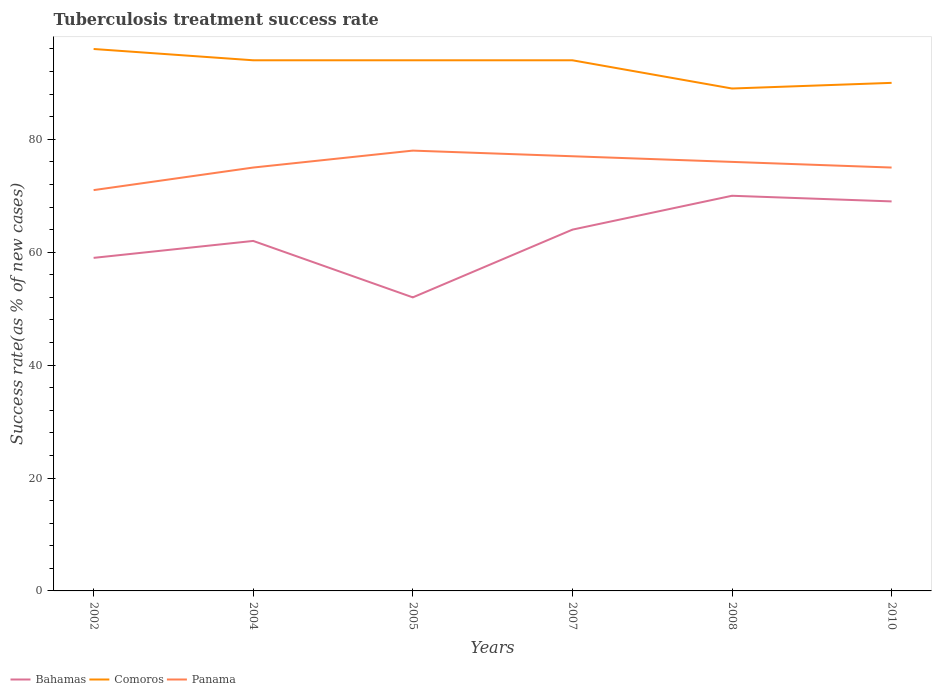Does the line corresponding to Bahamas intersect with the line corresponding to Panama?
Provide a short and direct response. No. In which year was the tuberculosis treatment success rate in Bahamas maximum?
Your answer should be compact. 2005. What is the total tuberculosis treatment success rate in Comoros in the graph?
Your response must be concise. 0. What is the difference between the highest and the second highest tuberculosis treatment success rate in Comoros?
Provide a short and direct response. 7. What is the difference between the highest and the lowest tuberculosis treatment success rate in Bahamas?
Offer a very short reply. 3. Is the tuberculosis treatment success rate in Panama strictly greater than the tuberculosis treatment success rate in Comoros over the years?
Ensure brevity in your answer.  Yes. How many lines are there?
Your answer should be very brief. 3. What is the difference between two consecutive major ticks on the Y-axis?
Ensure brevity in your answer.  20. Does the graph contain any zero values?
Provide a succinct answer. No. How many legend labels are there?
Keep it short and to the point. 3. How are the legend labels stacked?
Your response must be concise. Horizontal. What is the title of the graph?
Ensure brevity in your answer.  Tuberculosis treatment success rate. Does "Grenada" appear as one of the legend labels in the graph?
Provide a succinct answer. No. What is the label or title of the Y-axis?
Offer a very short reply. Success rate(as % of new cases). What is the Success rate(as % of new cases) of Bahamas in 2002?
Ensure brevity in your answer.  59. What is the Success rate(as % of new cases) of Comoros in 2002?
Your answer should be very brief. 96. What is the Success rate(as % of new cases) in Comoros in 2004?
Provide a succinct answer. 94. What is the Success rate(as % of new cases) in Bahamas in 2005?
Offer a very short reply. 52. What is the Success rate(as % of new cases) of Comoros in 2005?
Give a very brief answer. 94. What is the Success rate(as % of new cases) of Panama in 2005?
Ensure brevity in your answer.  78. What is the Success rate(as % of new cases) of Bahamas in 2007?
Give a very brief answer. 64. What is the Success rate(as % of new cases) in Comoros in 2007?
Offer a very short reply. 94. What is the Success rate(as % of new cases) in Bahamas in 2008?
Your response must be concise. 70. What is the Success rate(as % of new cases) in Comoros in 2008?
Provide a short and direct response. 89. What is the Success rate(as % of new cases) of Comoros in 2010?
Keep it short and to the point. 90. Across all years, what is the maximum Success rate(as % of new cases) in Bahamas?
Make the answer very short. 70. Across all years, what is the maximum Success rate(as % of new cases) of Comoros?
Offer a terse response. 96. Across all years, what is the maximum Success rate(as % of new cases) in Panama?
Your answer should be very brief. 78. Across all years, what is the minimum Success rate(as % of new cases) of Bahamas?
Keep it short and to the point. 52. Across all years, what is the minimum Success rate(as % of new cases) of Comoros?
Your answer should be compact. 89. Across all years, what is the minimum Success rate(as % of new cases) in Panama?
Offer a terse response. 71. What is the total Success rate(as % of new cases) in Bahamas in the graph?
Your answer should be very brief. 376. What is the total Success rate(as % of new cases) of Comoros in the graph?
Your answer should be compact. 557. What is the total Success rate(as % of new cases) in Panama in the graph?
Ensure brevity in your answer.  452. What is the difference between the Success rate(as % of new cases) in Panama in 2002 and that in 2004?
Give a very brief answer. -4. What is the difference between the Success rate(as % of new cases) of Panama in 2002 and that in 2007?
Provide a short and direct response. -6. What is the difference between the Success rate(as % of new cases) of Bahamas in 2002 and that in 2008?
Offer a very short reply. -11. What is the difference between the Success rate(as % of new cases) in Comoros in 2002 and that in 2008?
Your answer should be compact. 7. What is the difference between the Success rate(as % of new cases) in Comoros in 2002 and that in 2010?
Your answer should be compact. 6. What is the difference between the Success rate(as % of new cases) of Bahamas in 2004 and that in 2007?
Provide a short and direct response. -2. What is the difference between the Success rate(as % of new cases) in Panama in 2004 and that in 2008?
Your answer should be compact. -1. What is the difference between the Success rate(as % of new cases) in Panama in 2004 and that in 2010?
Keep it short and to the point. 0. What is the difference between the Success rate(as % of new cases) of Comoros in 2005 and that in 2007?
Provide a succinct answer. 0. What is the difference between the Success rate(as % of new cases) of Panama in 2005 and that in 2007?
Give a very brief answer. 1. What is the difference between the Success rate(as % of new cases) of Comoros in 2005 and that in 2008?
Your answer should be very brief. 5. What is the difference between the Success rate(as % of new cases) in Panama in 2005 and that in 2008?
Your response must be concise. 2. What is the difference between the Success rate(as % of new cases) in Bahamas in 2005 and that in 2010?
Your answer should be very brief. -17. What is the difference between the Success rate(as % of new cases) of Comoros in 2005 and that in 2010?
Your answer should be very brief. 4. What is the difference between the Success rate(as % of new cases) of Bahamas in 2007 and that in 2008?
Offer a very short reply. -6. What is the difference between the Success rate(as % of new cases) in Comoros in 2007 and that in 2010?
Give a very brief answer. 4. What is the difference between the Success rate(as % of new cases) of Panama in 2007 and that in 2010?
Keep it short and to the point. 2. What is the difference between the Success rate(as % of new cases) of Bahamas in 2008 and that in 2010?
Ensure brevity in your answer.  1. What is the difference between the Success rate(as % of new cases) in Comoros in 2008 and that in 2010?
Make the answer very short. -1. What is the difference between the Success rate(as % of new cases) in Panama in 2008 and that in 2010?
Your response must be concise. 1. What is the difference between the Success rate(as % of new cases) in Bahamas in 2002 and the Success rate(as % of new cases) in Comoros in 2004?
Ensure brevity in your answer.  -35. What is the difference between the Success rate(as % of new cases) of Bahamas in 2002 and the Success rate(as % of new cases) of Panama in 2004?
Provide a short and direct response. -16. What is the difference between the Success rate(as % of new cases) in Bahamas in 2002 and the Success rate(as % of new cases) in Comoros in 2005?
Offer a terse response. -35. What is the difference between the Success rate(as % of new cases) of Bahamas in 2002 and the Success rate(as % of new cases) of Panama in 2005?
Your answer should be very brief. -19. What is the difference between the Success rate(as % of new cases) of Comoros in 2002 and the Success rate(as % of new cases) of Panama in 2005?
Offer a very short reply. 18. What is the difference between the Success rate(as % of new cases) in Bahamas in 2002 and the Success rate(as % of new cases) in Comoros in 2007?
Your answer should be very brief. -35. What is the difference between the Success rate(as % of new cases) in Bahamas in 2002 and the Success rate(as % of new cases) in Comoros in 2008?
Provide a short and direct response. -30. What is the difference between the Success rate(as % of new cases) of Comoros in 2002 and the Success rate(as % of new cases) of Panama in 2008?
Offer a terse response. 20. What is the difference between the Success rate(as % of new cases) in Bahamas in 2002 and the Success rate(as % of new cases) in Comoros in 2010?
Give a very brief answer. -31. What is the difference between the Success rate(as % of new cases) of Bahamas in 2002 and the Success rate(as % of new cases) of Panama in 2010?
Provide a succinct answer. -16. What is the difference between the Success rate(as % of new cases) in Bahamas in 2004 and the Success rate(as % of new cases) in Comoros in 2005?
Your response must be concise. -32. What is the difference between the Success rate(as % of new cases) in Bahamas in 2004 and the Success rate(as % of new cases) in Comoros in 2007?
Your response must be concise. -32. What is the difference between the Success rate(as % of new cases) of Comoros in 2004 and the Success rate(as % of new cases) of Panama in 2010?
Give a very brief answer. 19. What is the difference between the Success rate(as % of new cases) in Bahamas in 2005 and the Success rate(as % of new cases) in Comoros in 2007?
Your answer should be very brief. -42. What is the difference between the Success rate(as % of new cases) in Comoros in 2005 and the Success rate(as % of new cases) in Panama in 2007?
Your answer should be compact. 17. What is the difference between the Success rate(as % of new cases) of Bahamas in 2005 and the Success rate(as % of new cases) of Comoros in 2008?
Your answer should be very brief. -37. What is the difference between the Success rate(as % of new cases) in Comoros in 2005 and the Success rate(as % of new cases) in Panama in 2008?
Make the answer very short. 18. What is the difference between the Success rate(as % of new cases) in Bahamas in 2005 and the Success rate(as % of new cases) in Comoros in 2010?
Give a very brief answer. -38. What is the difference between the Success rate(as % of new cases) of Bahamas in 2005 and the Success rate(as % of new cases) of Panama in 2010?
Your response must be concise. -23. What is the difference between the Success rate(as % of new cases) of Bahamas in 2007 and the Success rate(as % of new cases) of Comoros in 2008?
Provide a succinct answer. -25. What is the difference between the Success rate(as % of new cases) in Comoros in 2007 and the Success rate(as % of new cases) in Panama in 2010?
Your answer should be compact. 19. What is the difference between the Success rate(as % of new cases) of Bahamas in 2008 and the Success rate(as % of new cases) of Panama in 2010?
Keep it short and to the point. -5. What is the average Success rate(as % of new cases) of Bahamas per year?
Your response must be concise. 62.67. What is the average Success rate(as % of new cases) of Comoros per year?
Offer a very short reply. 92.83. What is the average Success rate(as % of new cases) of Panama per year?
Keep it short and to the point. 75.33. In the year 2002, what is the difference between the Success rate(as % of new cases) of Bahamas and Success rate(as % of new cases) of Comoros?
Your response must be concise. -37. In the year 2002, what is the difference between the Success rate(as % of new cases) in Bahamas and Success rate(as % of new cases) in Panama?
Provide a succinct answer. -12. In the year 2004, what is the difference between the Success rate(as % of new cases) of Bahamas and Success rate(as % of new cases) of Comoros?
Keep it short and to the point. -32. In the year 2004, what is the difference between the Success rate(as % of new cases) of Bahamas and Success rate(as % of new cases) of Panama?
Ensure brevity in your answer.  -13. In the year 2005, what is the difference between the Success rate(as % of new cases) of Bahamas and Success rate(as % of new cases) of Comoros?
Your answer should be very brief. -42. In the year 2007, what is the difference between the Success rate(as % of new cases) in Bahamas and Success rate(as % of new cases) in Panama?
Make the answer very short. -13. In the year 2008, what is the difference between the Success rate(as % of new cases) in Bahamas and Success rate(as % of new cases) in Panama?
Provide a succinct answer. -6. In the year 2008, what is the difference between the Success rate(as % of new cases) of Comoros and Success rate(as % of new cases) of Panama?
Give a very brief answer. 13. In the year 2010, what is the difference between the Success rate(as % of new cases) of Bahamas and Success rate(as % of new cases) of Comoros?
Your response must be concise. -21. In the year 2010, what is the difference between the Success rate(as % of new cases) in Bahamas and Success rate(as % of new cases) in Panama?
Your answer should be very brief. -6. What is the ratio of the Success rate(as % of new cases) of Bahamas in 2002 to that in 2004?
Keep it short and to the point. 0.95. What is the ratio of the Success rate(as % of new cases) in Comoros in 2002 to that in 2004?
Your answer should be very brief. 1.02. What is the ratio of the Success rate(as % of new cases) in Panama in 2002 to that in 2004?
Your answer should be very brief. 0.95. What is the ratio of the Success rate(as % of new cases) of Bahamas in 2002 to that in 2005?
Your response must be concise. 1.13. What is the ratio of the Success rate(as % of new cases) in Comoros in 2002 to that in 2005?
Your answer should be compact. 1.02. What is the ratio of the Success rate(as % of new cases) of Panama in 2002 to that in 2005?
Make the answer very short. 0.91. What is the ratio of the Success rate(as % of new cases) of Bahamas in 2002 to that in 2007?
Provide a succinct answer. 0.92. What is the ratio of the Success rate(as % of new cases) in Comoros in 2002 to that in 2007?
Give a very brief answer. 1.02. What is the ratio of the Success rate(as % of new cases) of Panama in 2002 to that in 2007?
Ensure brevity in your answer.  0.92. What is the ratio of the Success rate(as % of new cases) in Bahamas in 2002 to that in 2008?
Ensure brevity in your answer.  0.84. What is the ratio of the Success rate(as % of new cases) of Comoros in 2002 to that in 2008?
Your answer should be compact. 1.08. What is the ratio of the Success rate(as % of new cases) in Panama in 2002 to that in 2008?
Provide a short and direct response. 0.93. What is the ratio of the Success rate(as % of new cases) of Bahamas in 2002 to that in 2010?
Offer a terse response. 0.86. What is the ratio of the Success rate(as % of new cases) of Comoros in 2002 to that in 2010?
Your response must be concise. 1.07. What is the ratio of the Success rate(as % of new cases) of Panama in 2002 to that in 2010?
Your answer should be very brief. 0.95. What is the ratio of the Success rate(as % of new cases) in Bahamas in 2004 to that in 2005?
Provide a short and direct response. 1.19. What is the ratio of the Success rate(as % of new cases) of Comoros in 2004 to that in 2005?
Offer a very short reply. 1. What is the ratio of the Success rate(as % of new cases) in Panama in 2004 to that in 2005?
Provide a short and direct response. 0.96. What is the ratio of the Success rate(as % of new cases) of Bahamas in 2004 to that in 2007?
Keep it short and to the point. 0.97. What is the ratio of the Success rate(as % of new cases) in Comoros in 2004 to that in 2007?
Keep it short and to the point. 1. What is the ratio of the Success rate(as % of new cases) in Panama in 2004 to that in 2007?
Keep it short and to the point. 0.97. What is the ratio of the Success rate(as % of new cases) of Bahamas in 2004 to that in 2008?
Provide a succinct answer. 0.89. What is the ratio of the Success rate(as % of new cases) of Comoros in 2004 to that in 2008?
Give a very brief answer. 1.06. What is the ratio of the Success rate(as % of new cases) of Bahamas in 2004 to that in 2010?
Your answer should be very brief. 0.9. What is the ratio of the Success rate(as % of new cases) of Comoros in 2004 to that in 2010?
Make the answer very short. 1.04. What is the ratio of the Success rate(as % of new cases) in Panama in 2004 to that in 2010?
Offer a very short reply. 1. What is the ratio of the Success rate(as % of new cases) of Bahamas in 2005 to that in 2007?
Give a very brief answer. 0.81. What is the ratio of the Success rate(as % of new cases) in Bahamas in 2005 to that in 2008?
Offer a very short reply. 0.74. What is the ratio of the Success rate(as % of new cases) in Comoros in 2005 to that in 2008?
Offer a very short reply. 1.06. What is the ratio of the Success rate(as % of new cases) in Panama in 2005 to that in 2008?
Provide a short and direct response. 1.03. What is the ratio of the Success rate(as % of new cases) in Bahamas in 2005 to that in 2010?
Provide a short and direct response. 0.75. What is the ratio of the Success rate(as % of new cases) in Comoros in 2005 to that in 2010?
Your answer should be compact. 1.04. What is the ratio of the Success rate(as % of new cases) of Panama in 2005 to that in 2010?
Your answer should be compact. 1.04. What is the ratio of the Success rate(as % of new cases) of Bahamas in 2007 to that in 2008?
Ensure brevity in your answer.  0.91. What is the ratio of the Success rate(as % of new cases) of Comoros in 2007 to that in 2008?
Your answer should be very brief. 1.06. What is the ratio of the Success rate(as % of new cases) in Panama in 2007 to that in 2008?
Provide a succinct answer. 1.01. What is the ratio of the Success rate(as % of new cases) in Bahamas in 2007 to that in 2010?
Provide a succinct answer. 0.93. What is the ratio of the Success rate(as % of new cases) in Comoros in 2007 to that in 2010?
Your answer should be very brief. 1.04. What is the ratio of the Success rate(as % of new cases) in Panama in 2007 to that in 2010?
Your answer should be compact. 1.03. What is the ratio of the Success rate(as % of new cases) in Bahamas in 2008 to that in 2010?
Offer a very short reply. 1.01. What is the ratio of the Success rate(as % of new cases) in Comoros in 2008 to that in 2010?
Keep it short and to the point. 0.99. What is the ratio of the Success rate(as % of new cases) of Panama in 2008 to that in 2010?
Keep it short and to the point. 1.01. What is the difference between the highest and the second highest Success rate(as % of new cases) in Comoros?
Give a very brief answer. 2. What is the difference between the highest and the second highest Success rate(as % of new cases) of Panama?
Ensure brevity in your answer.  1. 